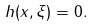<formula> <loc_0><loc_0><loc_500><loc_500>h ( x , \xi ) = 0 .</formula> 